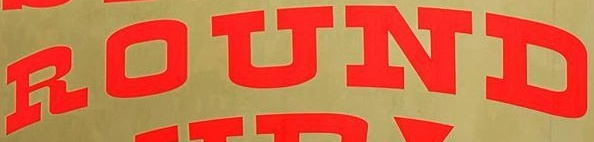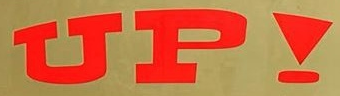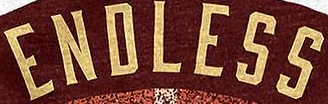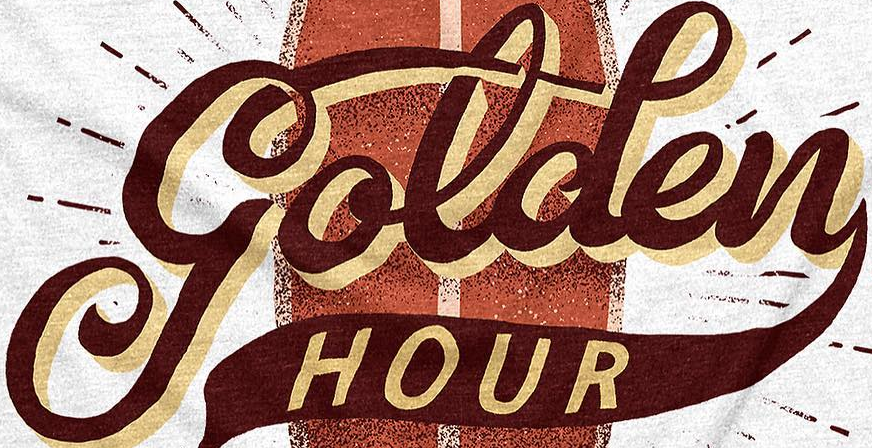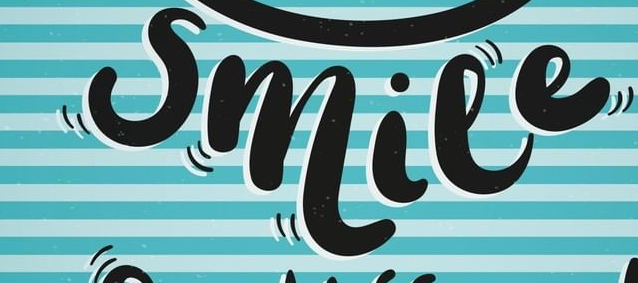Read the text from these images in sequence, separated by a semicolon. ROUND; UP!; ENDLESS; golden; smile 